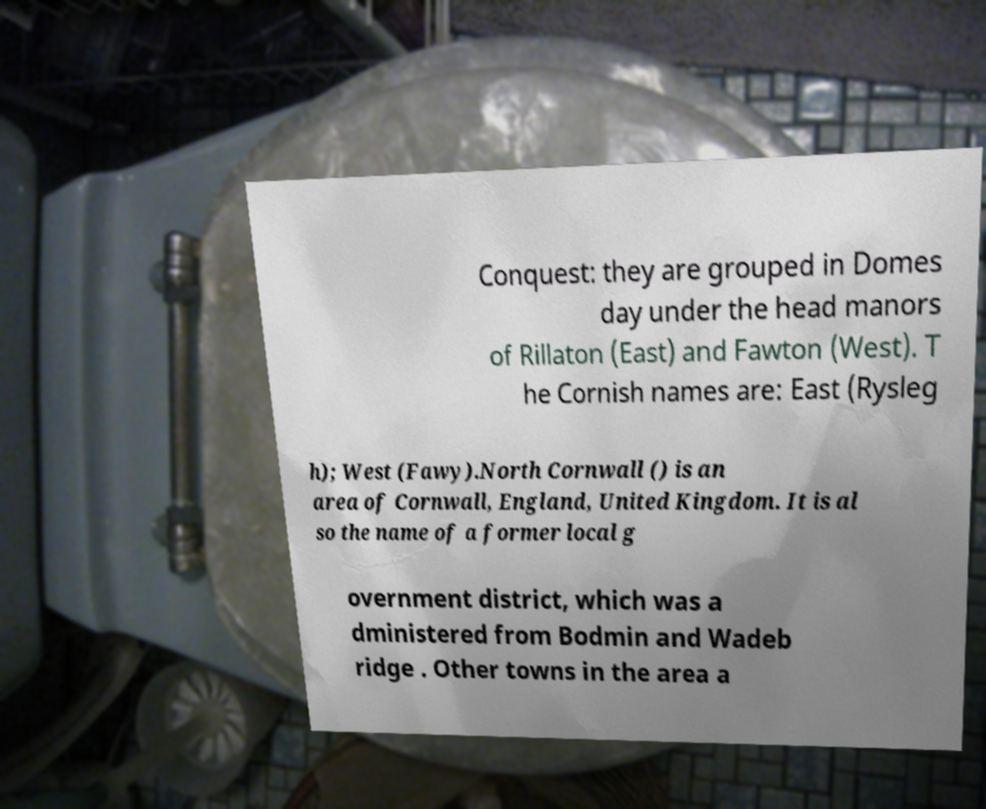What messages or text are displayed in this image? I need them in a readable, typed format. Conquest: they are grouped in Domes day under the head manors of Rillaton (East) and Fawton (West). T he Cornish names are: East (Rysleg h); West (Fawy).North Cornwall () is an area of Cornwall, England, United Kingdom. It is al so the name of a former local g overnment district, which was a dministered from Bodmin and Wadeb ridge . Other towns in the area a 